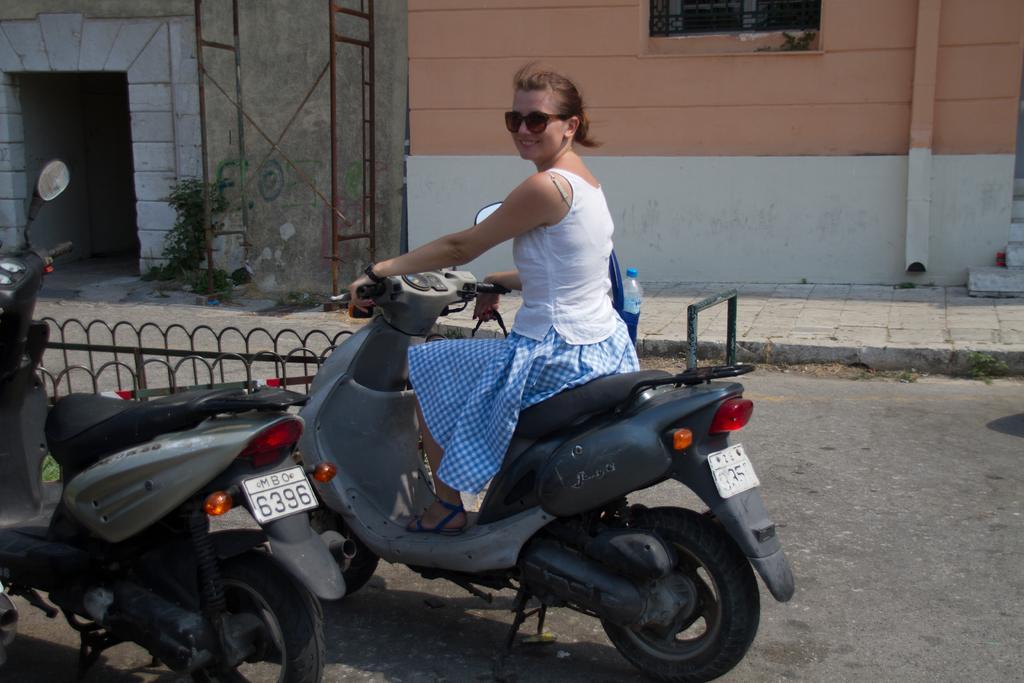Please provide a concise description of this image. In this image I can see a woman is sitting on the bike, smiling and giving pose for the picture. Beside her there is another bike on the road. On the right side, I can see footpath and two buildings and also there is a window. 